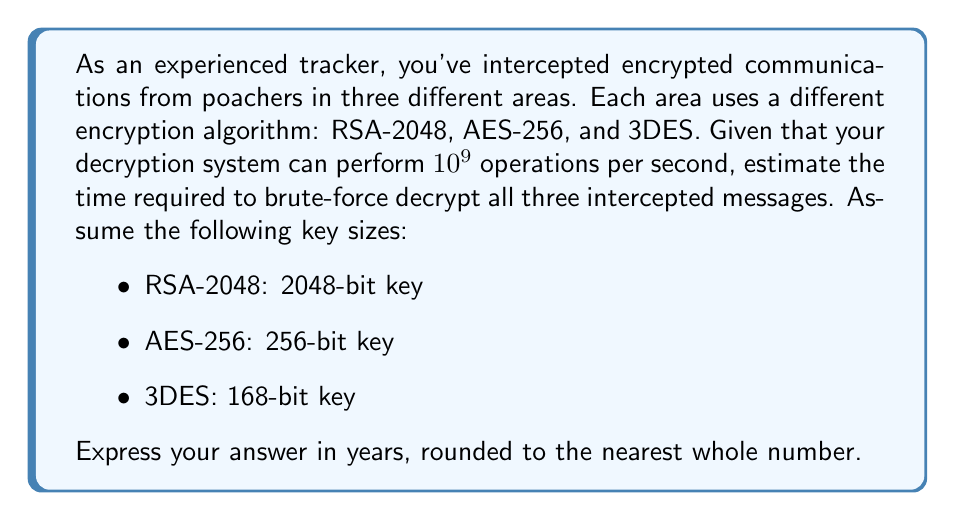Give your solution to this math problem. To estimate the time required to decrypt these messages using brute-force, we need to calculate the number of possible keys for each algorithm and divide by the number of operations our system can perform per second.

1. RSA-2048:
   Number of possible keys = $2^{2048}$
   Time to decrypt = $\frac{2^{2048}}{10^9}$ seconds

2. AES-256:
   Number of possible keys = $2^{256}$
   Time to decrypt = $\frac{2^{256}}{10^9}$ seconds

3. 3DES:
   Number of possible keys = $2^{168}$
   Time to decrypt = $\frac{2^{168}}{10^9}$ seconds

Total time in seconds:
$$T = \frac{2^{2048}}{10^9} + \frac{2^{256}}{10^9} + \frac{2^{168}}{10^9}$$

Simplify:
$$T = \frac{2^{2048} + 2^{256} + 2^{168}}{10^9}$$

Convert to years:
$$T_{years} = \frac{T}{60 \times 60 \times 24 \times 365.25}$$

Plugging in the values and calculating:
$$T_{years} \approx 3.31 \times 10^{307} + 1.84 \times 10^{60} + 3.69 \times 10^{31}$$

The RSA-2048 term dominates, so we can approximate:
$$T_{years} \approx 3.31 \times 10^{307}$$

Rounding to the nearest whole number:
$$T_{years} \approx 3 \times 10^{307}$$
Answer: $3 \times 10^{307}$ years 